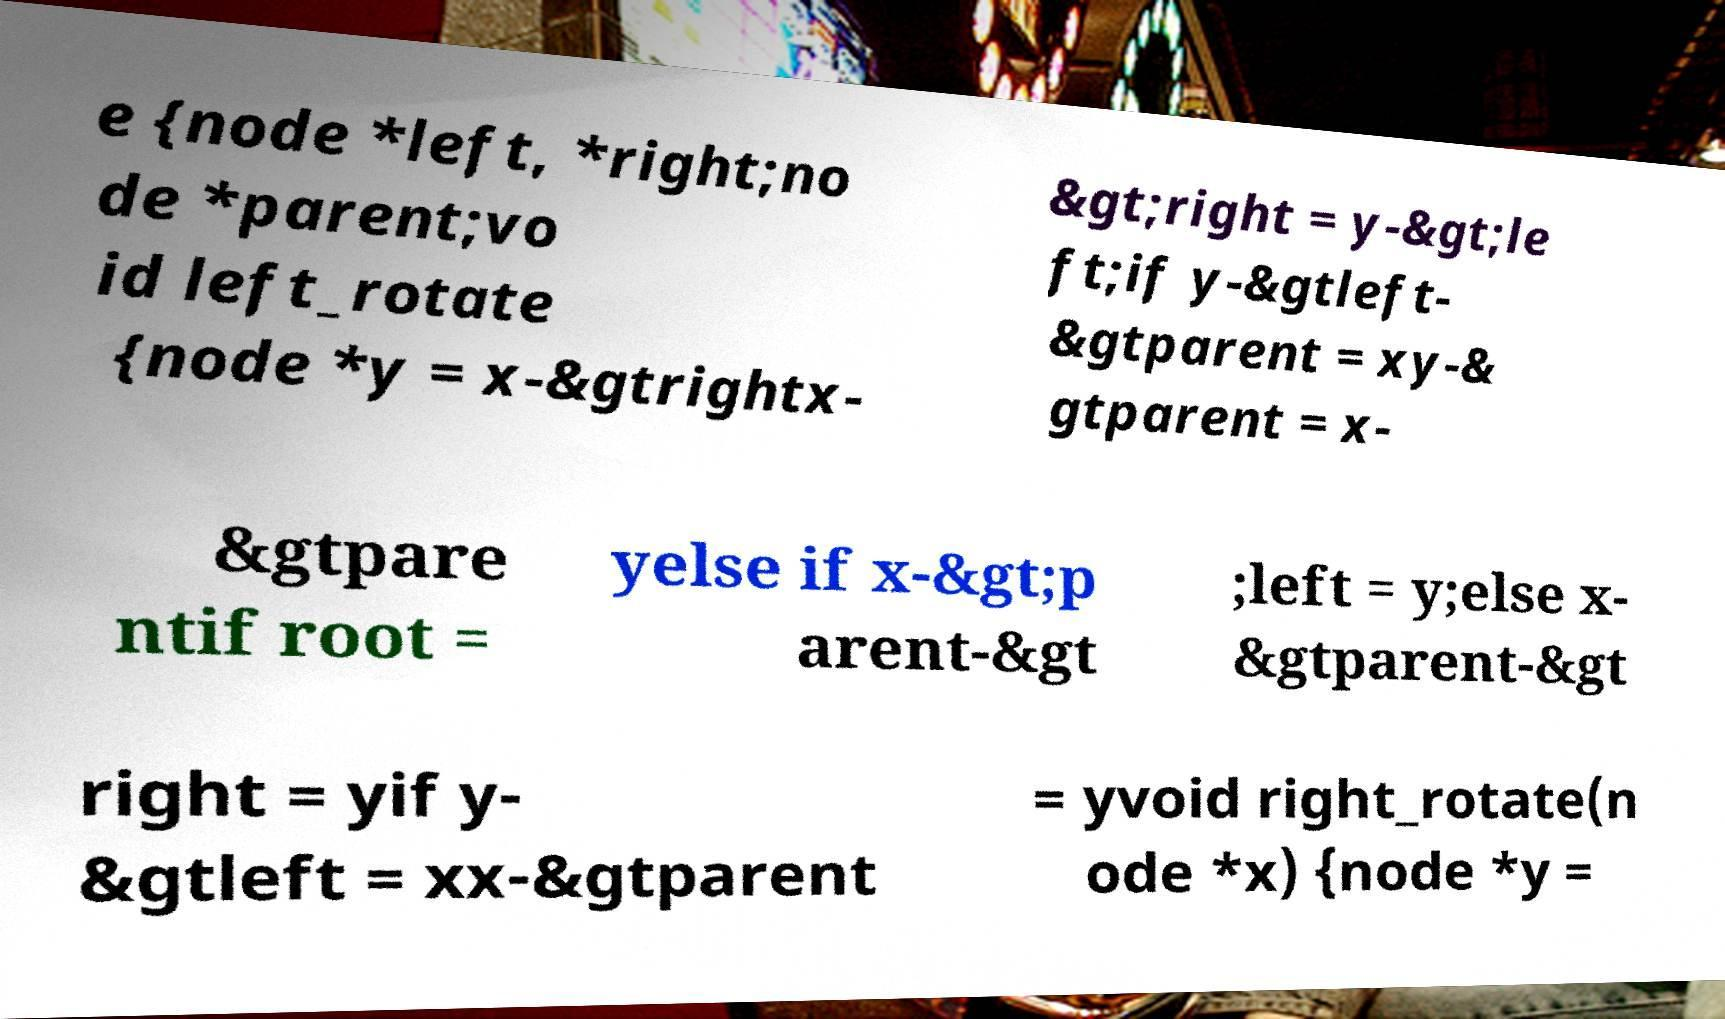Can you read and provide the text displayed in the image?This photo seems to have some interesting text. Can you extract and type it out for me? e {node *left, *right;no de *parent;vo id left_rotate {node *y = x-&gtrightx- &gt;right = y-&gt;le ft;if y-&gtleft- &gtparent = xy-& gtparent = x- &gtpare ntif root = yelse if x-&gt;p arent-&gt ;left = y;else x- &gtparent-&gt right = yif y- &gtleft = xx-&gtparent = yvoid right_rotate(n ode *x) {node *y = 